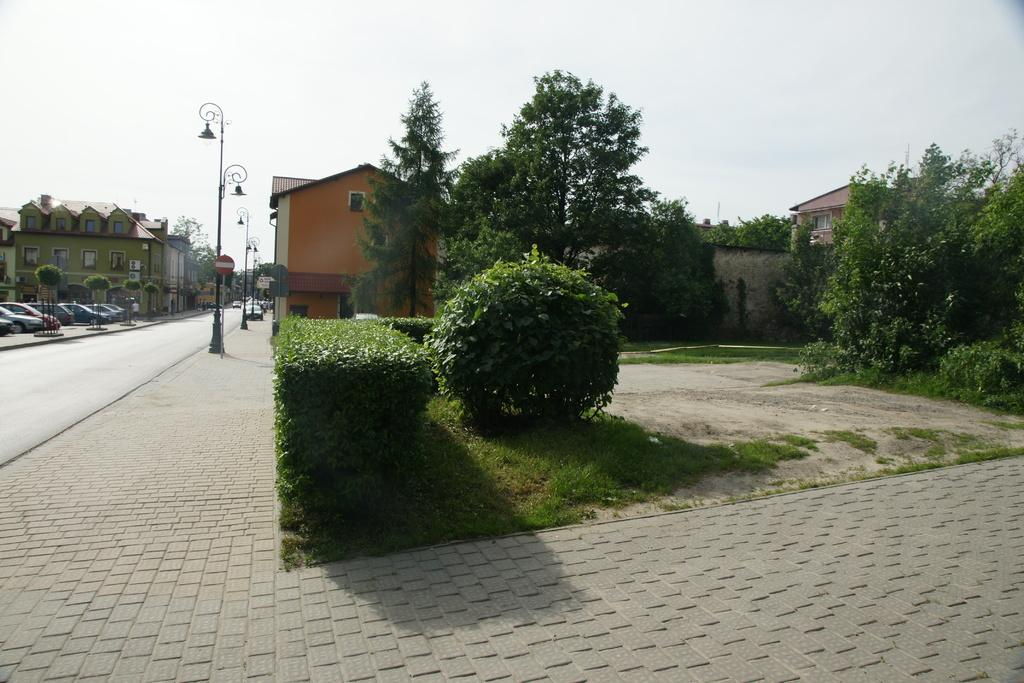What type of natural environment is visible in the background of the image? There is grass and trees in the background of the image. What type of man-made structures can be seen in the background of the image? There are buildings in the background of the image. What type of transportation is visible in the background of the image? Vehicles are visible in the background of the image. What type of lighting is present in the background of the image? Streetlights are present in the background of the image. What type of sky is visible in the background of the image? The sky is visible in the background of the image. How many bears are sitting on the streetlights in the image? There are no bears present in the image, and therefore no bears are sitting on the streetlights. What type of horse is visible in the background of the image? There are no horses present in the image. 